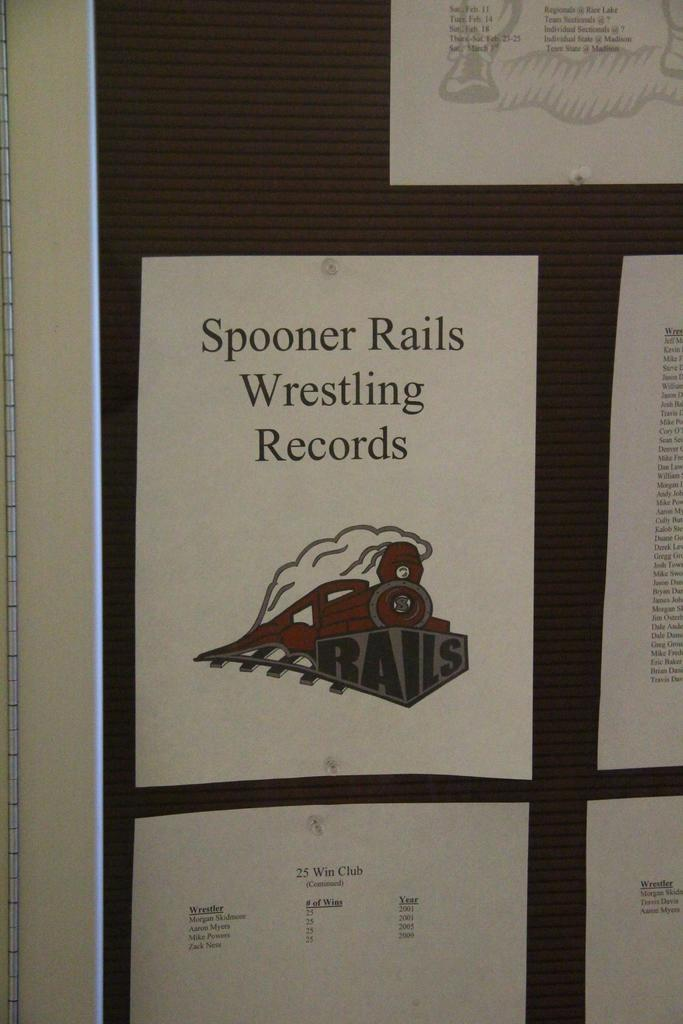<image>
Give a short and clear explanation of the subsequent image. A bulletin board with the Spooner Rails Wrestling Records tacked to it. 